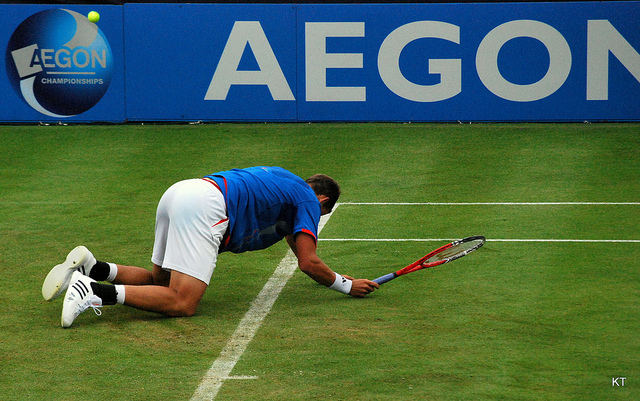<image>What does the sign in the background say? I am not sure what the sign in the background says. It may say 'aegon'. What does the sign in the background say? I am not sure what the sign in the background says. It can be seen as 'aegon'. 